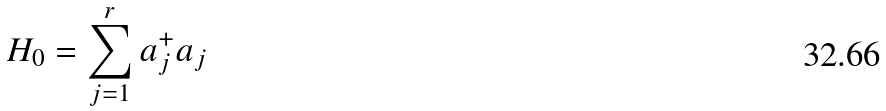Convert formula to latex. <formula><loc_0><loc_0><loc_500><loc_500>H _ { 0 } = \sum _ { j = 1 } ^ { r } a _ { j } ^ { + } a _ { j }</formula> 